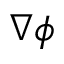<formula> <loc_0><loc_0><loc_500><loc_500>\nabla \phi</formula> 